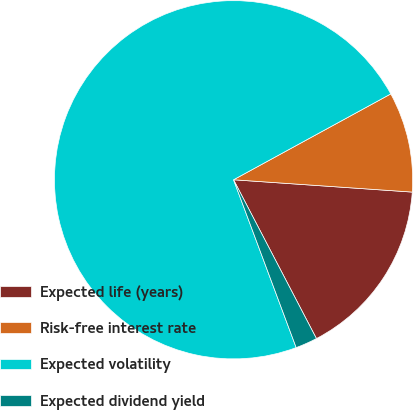Convert chart. <chart><loc_0><loc_0><loc_500><loc_500><pie_chart><fcel>Expected life (years)<fcel>Risk-free interest rate<fcel>Expected volatility<fcel>Expected dividend yield<nl><fcel>16.25%<fcel>9.05%<fcel>72.73%<fcel>1.97%<nl></chart> 